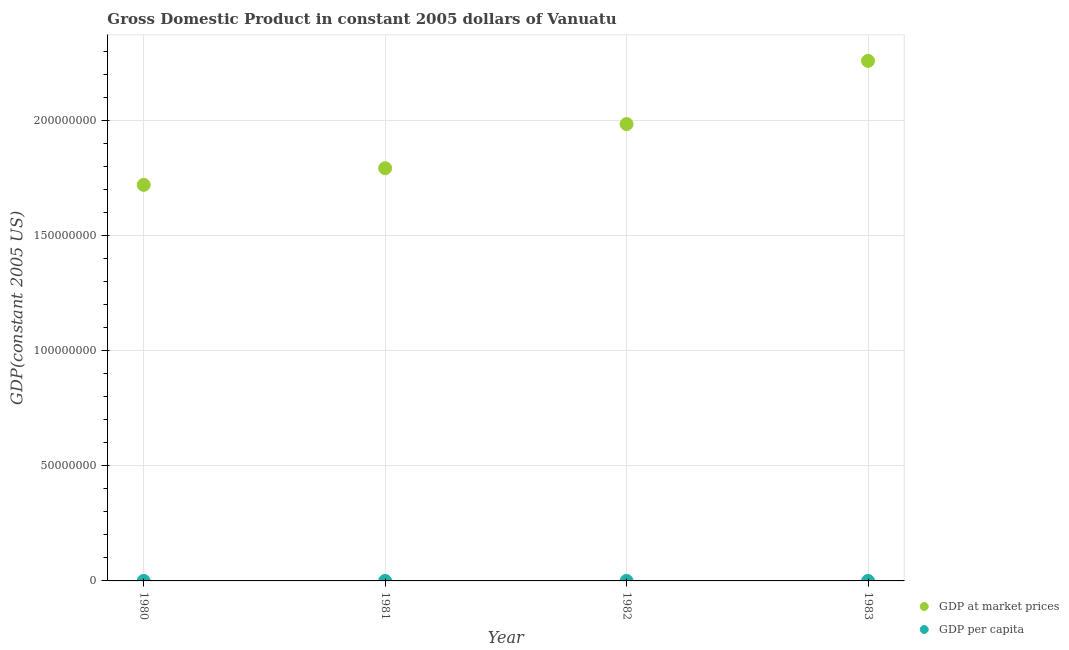How many different coloured dotlines are there?
Your answer should be very brief. 2. Is the number of dotlines equal to the number of legend labels?
Your response must be concise. Yes. What is the gdp per capita in 1982?
Offer a terse response. 1634.02. Across all years, what is the maximum gdp per capita?
Provide a short and direct response. 1817.91. Across all years, what is the minimum gdp per capita?
Keep it short and to the point. 1487.62. In which year was the gdp at market prices maximum?
Ensure brevity in your answer.  1983. What is the total gdp per capita in the graph?
Give a very brief answer. 6451.16. What is the difference between the gdp per capita in 1980 and that in 1983?
Your response must be concise. -330.29. What is the difference between the gdp per capita in 1983 and the gdp at market prices in 1980?
Your response must be concise. -1.72e+08. What is the average gdp per capita per year?
Your response must be concise. 1612.79. In the year 1980, what is the difference between the gdp at market prices and gdp per capita?
Keep it short and to the point. 1.72e+08. In how many years, is the gdp per capita greater than 200000000 US$?
Offer a terse response. 0. What is the ratio of the gdp at market prices in 1981 to that in 1983?
Make the answer very short. 0.79. Is the gdp at market prices in 1981 less than that in 1983?
Ensure brevity in your answer.  Yes. What is the difference between the highest and the second highest gdp per capita?
Keep it short and to the point. 183.89. What is the difference between the highest and the lowest gdp per capita?
Provide a short and direct response. 330.29. Is the sum of the gdp at market prices in 1980 and 1982 greater than the maximum gdp per capita across all years?
Your answer should be very brief. Yes. Does the gdp per capita monotonically increase over the years?
Ensure brevity in your answer.  Yes. What is the difference between two consecutive major ticks on the Y-axis?
Your answer should be very brief. 5.00e+07. Where does the legend appear in the graph?
Provide a short and direct response. Bottom right. How many legend labels are there?
Give a very brief answer. 2. What is the title of the graph?
Your answer should be very brief. Gross Domestic Product in constant 2005 dollars of Vanuatu. Does "Transport services" appear as one of the legend labels in the graph?
Provide a succinct answer. No. What is the label or title of the X-axis?
Your answer should be compact. Year. What is the label or title of the Y-axis?
Your response must be concise. GDP(constant 2005 US). What is the GDP(constant 2005 US) of GDP at market prices in 1980?
Make the answer very short. 1.72e+08. What is the GDP(constant 2005 US) in GDP per capita in 1980?
Ensure brevity in your answer.  1487.62. What is the GDP(constant 2005 US) in GDP at market prices in 1981?
Your answer should be compact. 1.79e+08. What is the GDP(constant 2005 US) in GDP per capita in 1981?
Provide a succinct answer. 1511.61. What is the GDP(constant 2005 US) in GDP at market prices in 1982?
Your answer should be very brief. 1.98e+08. What is the GDP(constant 2005 US) of GDP per capita in 1982?
Give a very brief answer. 1634.02. What is the GDP(constant 2005 US) in GDP at market prices in 1983?
Ensure brevity in your answer.  2.26e+08. What is the GDP(constant 2005 US) of GDP per capita in 1983?
Offer a terse response. 1817.91. Across all years, what is the maximum GDP(constant 2005 US) of GDP at market prices?
Ensure brevity in your answer.  2.26e+08. Across all years, what is the maximum GDP(constant 2005 US) of GDP per capita?
Ensure brevity in your answer.  1817.91. Across all years, what is the minimum GDP(constant 2005 US) of GDP at market prices?
Give a very brief answer. 1.72e+08. Across all years, what is the minimum GDP(constant 2005 US) of GDP per capita?
Offer a very short reply. 1487.62. What is the total GDP(constant 2005 US) of GDP at market prices in the graph?
Your answer should be very brief. 7.76e+08. What is the total GDP(constant 2005 US) in GDP per capita in the graph?
Your answer should be very brief. 6451.16. What is the difference between the GDP(constant 2005 US) in GDP at market prices in 1980 and that in 1981?
Give a very brief answer. -7.22e+06. What is the difference between the GDP(constant 2005 US) of GDP per capita in 1980 and that in 1981?
Give a very brief answer. -23.99. What is the difference between the GDP(constant 2005 US) of GDP at market prices in 1980 and that in 1982?
Make the answer very short. -2.64e+07. What is the difference between the GDP(constant 2005 US) of GDP per capita in 1980 and that in 1982?
Your response must be concise. -146.39. What is the difference between the GDP(constant 2005 US) in GDP at market prices in 1980 and that in 1983?
Your answer should be very brief. -5.39e+07. What is the difference between the GDP(constant 2005 US) in GDP per capita in 1980 and that in 1983?
Offer a terse response. -330.29. What is the difference between the GDP(constant 2005 US) of GDP at market prices in 1981 and that in 1982?
Ensure brevity in your answer.  -1.92e+07. What is the difference between the GDP(constant 2005 US) in GDP per capita in 1981 and that in 1982?
Provide a short and direct response. -122.4. What is the difference between the GDP(constant 2005 US) of GDP at market prices in 1981 and that in 1983?
Your answer should be compact. -4.66e+07. What is the difference between the GDP(constant 2005 US) of GDP per capita in 1981 and that in 1983?
Keep it short and to the point. -306.3. What is the difference between the GDP(constant 2005 US) of GDP at market prices in 1982 and that in 1983?
Give a very brief answer. -2.74e+07. What is the difference between the GDP(constant 2005 US) of GDP per capita in 1982 and that in 1983?
Provide a short and direct response. -183.89. What is the difference between the GDP(constant 2005 US) in GDP at market prices in 1980 and the GDP(constant 2005 US) in GDP per capita in 1981?
Provide a succinct answer. 1.72e+08. What is the difference between the GDP(constant 2005 US) in GDP at market prices in 1980 and the GDP(constant 2005 US) in GDP per capita in 1982?
Your answer should be very brief. 1.72e+08. What is the difference between the GDP(constant 2005 US) of GDP at market prices in 1980 and the GDP(constant 2005 US) of GDP per capita in 1983?
Provide a succinct answer. 1.72e+08. What is the difference between the GDP(constant 2005 US) of GDP at market prices in 1981 and the GDP(constant 2005 US) of GDP per capita in 1982?
Provide a succinct answer. 1.79e+08. What is the difference between the GDP(constant 2005 US) of GDP at market prices in 1981 and the GDP(constant 2005 US) of GDP per capita in 1983?
Ensure brevity in your answer.  1.79e+08. What is the difference between the GDP(constant 2005 US) in GDP at market prices in 1982 and the GDP(constant 2005 US) in GDP per capita in 1983?
Provide a succinct answer. 1.98e+08. What is the average GDP(constant 2005 US) of GDP at market prices per year?
Your response must be concise. 1.94e+08. What is the average GDP(constant 2005 US) of GDP per capita per year?
Give a very brief answer. 1612.79. In the year 1980, what is the difference between the GDP(constant 2005 US) of GDP at market prices and GDP(constant 2005 US) of GDP per capita?
Your answer should be compact. 1.72e+08. In the year 1981, what is the difference between the GDP(constant 2005 US) in GDP at market prices and GDP(constant 2005 US) in GDP per capita?
Your answer should be very brief. 1.79e+08. In the year 1982, what is the difference between the GDP(constant 2005 US) in GDP at market prices and GDP(constant 2005 US) in GDP per capita?
Provide a short and direct response. 1.98e+08. In the year 1983, what is the difference between the GDP(constant 2005 US) of GDP at market prices and GDP(constant 2005 US) of GDP per capita?
Offer a very short reply. 2.26e+08. What is the ratio of the GDP(constant 2005 US) of GDP at market prices in 1980 to that in 1981?
Provide a short and direct response. 0.96. What is the ratio of the GDP(constant 2005 US) of GDP per capita in 1980 to that in 1981?
Offer a terse response. 0.98. What is the ratio of the GDP(constant 2005 US) in GDP at market prices in 1980 to that in 1982?
Offer a terse response. 0.87. What is the ratio of the GDP(constant 2005 US) of GDP per capita in 1980 to that in 1982?
Provide a short and direct response. 0.91. What is the ratio of the GDP(constant 2005 US) in GDP at market prices in 1980 to that in 1983?
Your response must be concise. 0.76. What is the ratio of the GDP(constant 2005 US) in GDP per capita in 1980 to that in 1983?
Keep it short and to the point. 0.82. What is the ratio of the GDP(constant 2005 US) in GDP at market prices in 1981 to that in 1982?
Provide a succinct answer. 0.9. What is the ratio of the GDP(constant 2005 US) of GDP per capita in 1981 to that in 1982?
Keep it short and to the point. 0.93. What is the ratio of the GDP(constant 2005 US) of GDP at market prices in 1981 to that in 1983?
Offer a terse response. 0.79. What is the ratio of the GDP(constant 2005 US) in GDP per capita in 1981 to that in 1983?
Your answer should be very brief. 0.83. What is the ratio of the GDP(constant 2005 US) in GDP at market prices in 1982 to that in 1983?
Give a very brief answer. 0.88. What is the ratio of the GDP(constant 2005 US) of GDP per capita in 1982 to that in 1983?
Ensure brevity in your answer.  0.9. What is the difference between the highest and the second highest GDP(constant 2005 US) of GDP at market prices?
Ensure brevity in your answer.  2.74e+07. What is the difference between the highest and the second highest GDP(constant 2005 US) in GDP per capita?
Your answer should be compact. 183.89. What is the difference between the highest and the lowest GDP(constant 2005 US) of GDP at market prices?
Make the answer very short. 5.39e+07. What is the difference between the highest and the lowest GDP(constant 2005 US) of GDP per capita?
Give a very brief answer. 330.29. 